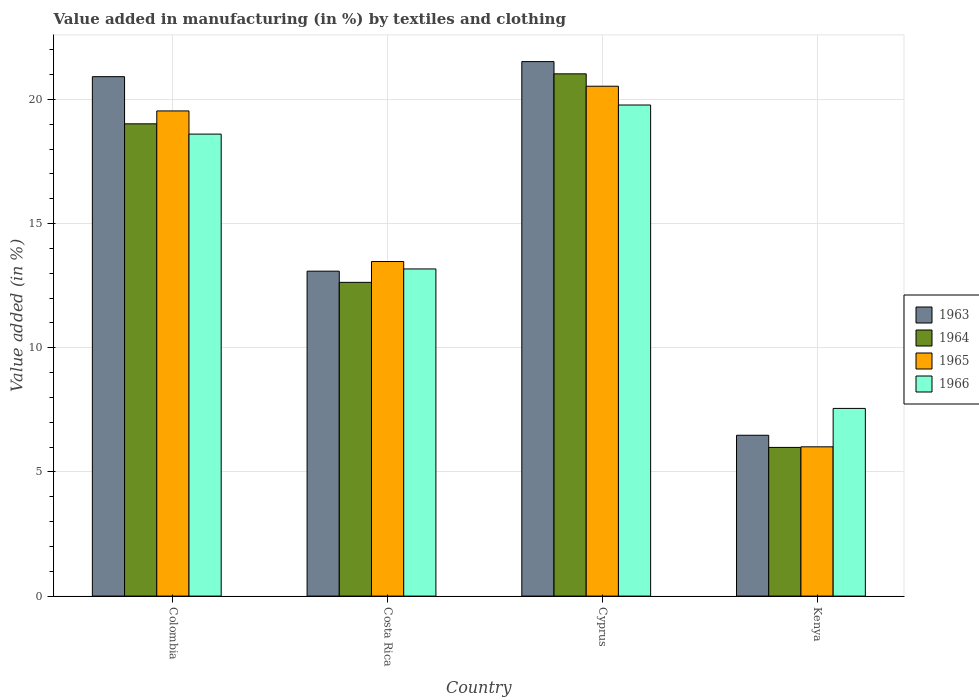How many groups of bars are there?
Keep it short and to the point. 4. Are the number of bars per tick equal to the number of legend labels?
Make the answer very short. Yes. How many bars are there on the 4th tick from the left?
Offer a terse response. 4. What is the label of the 3rd group of bars from the left?
Give a very brief answer. Cyprus. What is the percentage of value added in manufacturing by textiles and clothing in 1963 in Kenya?
Your answer should be compact. 6.48. Across all countries, what is the maximum percentage of value added in manufacturing by textiles and clothing in 1965?
Your response must be concise. 20.53. Across all countries, what is the minimum percentage of value added in manufacturing by textiles and clothing in 1963?
Your answer should be compact. 6.48. In which country was the percentage of value added in manufacturing by textiles and clothing in 1963 maximum?
Keep it short and to the point. Cyprus. In which country was the percentage of value added in manufacturing by textiles and clothing in 1965 minimum?
Keep it short and to the point. Kenya. What is the total percentage of value added in manufacturing by textiles and clothing in 1964 in the graph?
Your response must be concise. 58.67. What is the difference between the percentage of value added in manufacturing by textiles and clothing in 1964 in Cyprus and that in Kenya?
Your answer should be compact. 15.04. What is the difference between the percentage of value added in manufacturing by textiles and clothing in 1965 in Colombia and the percentage of value added in manufacturing by textiles and clothing in 1964 in Costa Rica?
Offer a very short reply. 6.9. What is the average percentage of value added in manufacturing by textiles and clothing in 1965 per country?
Your answer should be very brief. 14.89. What is the difference between the percentage of value added in manufacturing by textiles and clothing of/in 1965 and percentage of value added in manufacturing by textiles and clothing of/in 1966 in Colombia?
Ensure brevity in your answer.  0.93. What is the ratio of the percentage of value added in manufacturing by textiles and clothing in 1963 in Cyprus to that in Kenya?
Keep it short and to the point. 3.32. Is the percentage of value added in manufacturing by textiles and clothing in 1965 in Cyprus less than that in Kenya?
Provide a short and direct response. No. What is the difference between the highest and the second highest percentage of value added in manufacturing by textiles and clothing in 1965?
Offer a very short reply. -0.99. What is the difference between the highest and the lowest percentage of value added in manufacturing by textiles and clothing in 1963?
Make the answer very short. 15.05. What does the 4th bar from the left in Cyprus represents?
Your answer should be compact. 1966. What does the 1st bar from the right in Cyprus represents?
Offer a very short reply. 1966. Is it the case that in every country, the sum of the percentage of value added in manufacturing by textiles and clothing in 1963 and percentage of value added in manufacturing by textiles and clothing in 1964 is greater than the percentage of value added in manufacturing by textiles and clothing in 1966?
Offer a very short reply. Yes. How many bars are there?
Offer a very short reply. 16. Are all the bars in the graph horizontal?
Your answer should be compact. No. What is the difference between two consecutive major ticks on the Y-axis?
Provide a succinct answer. 5. Are the values on the major ticks of Y-axis written in scientific E-notation?
Give a very brief answer. No. Does the graph contain grids?
Offer a very short reply. Yes. Where does the legend appear in the graph?
Your answer should be compact. Center right. How are the legend labels stacked?
Your answer should be very brief. Vertical. What is the title of the graph?
Offer a terse response. Value added in manufacturing (in %) by textiles and clothing. Does "1970" appear as one of the legend labels in the graph?
Give a very brief answer. No. What is the label or title of the Y-axis?
Your answer should be compact. Value added (in %). What is the Value added (in %) in 1963 in Colombia?
Your response must be concise. 20.92. What is the Value added (in %) in 1964 in Colombia?
Offer a terse response. 19.02. What is the Value added (in %) of 1965 in Colombia?
Offer a very short reply. 19.54. What is the Value added (in %) of 1966 in Colombia?
Your answer should be very brief. 18.6. What is the Value added (in %) of 1963 in Costa Rica?
Offer a very short reply. 13.08. What is the Value added (in %) of 1964 in Costa Rica?
Offer a terse response. 12.63. What is the Value added (in %) of 1965 in Costa Rica?
Offer a very short reply. 13.47. What is the Value added (in %) in 1966 in Costa Rica?
Your answer should be very brief. 13.17. What is the Value added (in %) of 1963 in Cyprus?
Your response must be concise. 21.52. What is the Value added (in %) of 1964 in Cyprus?
Your answer should be very brief. 21.03. What is the Value added (in %) in 1965 in Cyprus?
Offer a terse response. 20.53. What is the Value added (in %) in 1966 in Cyprus?
Provide a succinct answer. 19.78. What is the Value added (in %) in 1963 in Kenya?
Your response must be concise. 6.48. What is the Value added (in %) in 1964 in Kenya?
Offer a very short reply. 5.99. What is the Value added (in %) in 1965 in Kenya?
Your answer should be very brief. 6.01. What is the Value added (in %) of 1966 in Kenya?
Your answer should be very brief. 7.56. Across all countries, what is the maximum Value added (in %) in 1963?
Make the answer very short. 21.52. Across all countries, what is the maximum Value added (in %) of 1964?
Keep it short and to the point. 21.03. Across all countries, what is the maximum Value added (in %) in 1965?
Give a very brief answer. 20.53. Across all countries, what is the maximum Value added (in %) in 1966?
Give a very brief answer. 19.78. Across all countries, what is the minimum Value added (in %) in 1963?
Offer a terse response. 6.48. Across all countries, what is the minimum Value added (in %) of 1964?
Make the answer very short. 5.99. Across all countries, what is the minimum Value added (in %) in 1965?
Provide a succinct answer. 6.01. Across all countries, what is the minimum Value added (in %) of 1966?
Give a very brief answer. 7.56. What is the total Value added (in %) of 1963 in the graph?
Provide a short and direct response. 62. What is the total Value added (in %) of 1964 in the graph?
Provide a short and direct response. 58.67. What is the total Value added (in %) of 1965 in the graph?
Give a very brief answer. 59.55. What is the total Value added (in %) of 1966 in the graph?
Provide a short and direct response. 59.11. What is the difference between the Value added (in %) of 1963 in Colombia and that in Costa Rica?
Your answer should be very brief. 7.83. What is the difference between the Value added (in %) in 1964 in Colombia and that in Costa Rica?
Your response must be concise. 6.38. What is the difference between the Value added (in %) of 1965 in Colombia and that in Costa Rica?
Provide a succinct answer. 6.06. What is the difference between the Value added (in %) in 1966 in Colombia and that in Costa Rica?
Offer a terse response. 5.43. What is the difference between the Value added (in %) of 1963 in Colombia and that in Cyprus?
Keep it short and to the point. -0.61. What is the difference between the Value added (in %) in 1964 in Colombia and that in Cyprus?
Your response must be concise. -2.01. What is the difference between the Value added (in %) of 1965 in Colombia and that in Cyprus?
Provide a short and direct response. -0.99. What is the difference between the Value added (in %) in 1966 in Colombia and that in Cyprus?
Your answer should be very brief. -1.17. What is the difference between the Value added (in %) in 1963 in Colombia and that in Kenya?
Your answer should be compact. 14.44. What is the difference between the Value added (in %) of 1964 in Colombia and that in Kenya?
Provide a succinct answer. 13.03. What is the difference between the Value added (in %) of 1965 in Colombia and that in Kenya?
Offer a very short reply. 13.53. What is the difference between the Value added (in %) in 1966 in Colombia and that in Kenya?
Your answer should be compact. 11.05. What is the difference between the Value added (in %) in 1963 in Costa Rica and that in Cyprus?
Give a very brief answer. -8.44. What is the difference between the Value added (in %) in 1964 in Costa Rica and that in Cyprus?
Make the answer very short. -8.4. What is the difference between the Value added (in %) of 1965 in Costa Rica and that in Cyprus?
Provide a short and direct response. -7.06. What is the difference between the Value added (in %) of 1966 in Costa Rica and that in Cyprus?
Offer a very short reply. -6.6. What is the difference between the Value added (in %) in 1963 in Costa Rica and that in Kenya?
Offer a very short reply. 6.61. What is the difference between the Value added (in %) of 1964 in Costa Rica and that in Kenya?
Make the answer very short. 6.65. What is the difference between the Value added (in %) in 1965 in Costa Rica and that in Kenya?
Ensure brevity in your answer.  7.46. What is the difference between the Value added (in %) in 1966 in Costa Rica and that in Kenya?
Make the answer very short. 5.62. What is the difference between the Value added (in %) of 1963 in Cyprus and that in Kenya?
Ensure brevity in your answer.  15.05. What is the difference between the Value added (in %) of 1964 in Cyprus and that in Kenya?
Your answer should be compact. 15.04. What is the difference between the Value added (in %) in 1965 in Cyprus and that in Kenya?
Keep it short and to the point. 14.52. What is the difference between the Value added (in %) in 1966 in Cyprus and that in Kenya?
Ensure brevity in your answer.  12.22. What is the difference between the Value added (in %) of 1963 in Colombia and the Value added (in %) of 1964 in Costa Rica?
Keep it short and to the point. 8.28. What is the difference between the Value added (in %) in 1963 in Colombia and the Value added (in %) in 1965 in Costa Rica?
Your answer should be very brief. 7.44. What is the difference between the Value added (in %) in 1963 in Colombia and the Value added (in %) in 1966 in Costa Rica?
Provide a succinct answer. 7.74. What is the difference between the Value added (in %) in 1964 in Colombia and the Value added (in %) in 1965 in Costa Rica?
Give a very brief answer. 5.55. What is the difference between the Value added (in %) of 1964 in Colombia and the Value added (in %) of 1966 in Costa Rica?
Provide a short and direct response. 5.84. What is the difference between the Value added (in %) in 1965 in Colombia and the Value added (in %) in 1966 in Costa Rica?
Give a very brief answer. 6.36. What is the difference between the Value added (in %) in 1963 in Colombia and the Value added (in %) in 1964 in Cyprus?
Make the answer very short. -0.11. What is the difference between the Value added (in %) in 1963 in Colombia and the Value added (in %) in 1965 in Cyprus?
Provide a short and direct response. 0.39. What is the difference between the Value added (in %) of 1963 in Colombia and the Value added (in %) of 1966 in Cyprus?
Your response must be concise. 1.14. What is the difference between the Value added (in %) in 1964 in Colombia and the Value added (in %) in 1965 in Cyprus?
Ensure brevity in your answer.  -1.51. What is the difference between the Value added (in %) in 1964 in Colombia and the Value added (in %) in 1966 in Cyprus?
Offer a terse response. -0.76. What is the difference between the Value added (in %) in 1965 in Colombia and the Value added (in %) in 1966 in Cyprus?
Offer a very short reply. -0.24. What is the difference between the Value added (in %) in 1963 in Colombia and the Value added (in %) in 1964 in Kenya?
Your answer should be compact. 14.93. What is the difference between the Value added (in %) of 1963 in Colombia and the Value added (in %) of 1965 in Kenya?
Offer a terse response. 14.91. What is the difference between the Value added (in %) in 1963 in Colombia and the Value added (in %) in 1966 in Kenya?
Provide a short and direct response. 13.36. What is the difference between the Value added (in %) in 1964 in Colombia and the Value added (in %) in 1965 in Kenya?
Offer a very short reply. 13.01. What is the difference between the Value added (in %) in 1964 in Colombia and the Value added (in %) in 1966 in Kenya?
Provide a succinct answer. 11.46. What is the difference between the Value added (in %) of 1965 in Colombia and the Value added (in %) of 1966 in Kenya?
Offer a terse response. 11.98. What is the difference between the Value added (in %) of 1963 in Costa Rica and the Value added (in %) of 1964 in Cyprus?
Provide a short and direct response. -7.95. What is the difference between the Value added (in %) of 1963 in Costa Rica and the Value added (in %) of 1965 in Cyprus?
Your answer should be very brief. -7.45. What is the difference between the Value added (in %) of 1963 in Costa Rica and the Value added (in %) of 1966 in Cyprus?
Provide a short and direct response. -6.69. What is the difference between the Value added (in %) of 1964 in Costa Rica and the Value added (in %) of 1965 in Cyprus?
Keep it short and to the point. -7.9. What is the difference between the Value added (in %) in 1964 in Costa Rica and the Value added (in %) in 1966 in Cyprus?
Ensure brevity in your answer.  -7.14. What is the difference between the Value added (in %) of 1965 in Costa Rica and the Value added (in %) of 1966 in Cyprus?
Your answer should be compact. -6.3. What is the difference between the Value added (in %) of 1963 in Costa Rica and the Value added (in %) of 1964 in Kenya?
Offer a very short reply. 7.1. What is the difference between the Value added (in %) in 1963 in Costa Rica and the Value added (in %) in 1965 in Kenya?
Offer a very short reply. 7.07. What is the difference between the Value added (in %) in 1963 in Costa Rica and the Value added (in %) in 1966 in Kenya?
Make the answer very short. 5.53. What is the difference between the Value added (in %) in 1964 in Costa Rica and the Value added (in %) in 1965 in Kenya?
Your answer should be compact. 6.62. What is the difference between the Value added (in %) in 1964 in Costa Rica and the Value added (in %) in 1966 in Kenya?
Give a very brief answer. 5.08. What is the difference between the Value added (in %) in 1965 in Costa Rica and the Value added (in %) in 1966 in Kenya?
Your response must be concise. 5.91. What is the difference between the Value added (in %) of 1963 in Cyprus and the Value added (in %) of 1964 in Kenya?
Provide a succinct answer. 15.54. What is the difference between the Value added (in %) of 1963 in Cyprus and the Value added (in %) of 1965 in Kenya?
Your answer should be compact. 15.51. What is the difference between the Value added (in %) in 1963 in Cyprus and the Value added (in %) in 1966 in Kenya?
Provide a succinct answer. 13.97. What is the difference between the Value added (in %) in 1964 in Cyprus and the Value added (in %) in 1965 in Kenya?
Offer a terse response. 15.02. What is the difference between the Value added (in %) of 1964 in Cyprus and the Value added (in %) of 1966 in Kenya?
Keep it short and to the point. 13.47. What is the difference between the Value added (in %) of 1965 in Cyprus and the Value added (in %) of 1966 in Kenya?
Your answer should be very brief. 12.97. What is the average Value added (in %) of 1963 per country?
Provide a succinct answer. 15.5. What is the average Value added (in %) in 1964 per country?
Give a very brief answer. 14.67. What is the average Value added (in %) of 1965 per country?
Your response must be concise. 14.89. What is the average Value added (in %) in 1966 per country?
Give a very brief answer. 14.78. What is the difference between the Value added (in %) in 1963 and Value added (in %) in 1964 in Colombia?
Keep it short and to the point. 1.9. What is the difference between the Value added (in %) in 1963 and Value added (in %) in 1965 in Colombia?
Your answer should be compact. 1.38. What is the difference between the Value added (in %) of 1963 and Value added (in %) of 1966 in Colombia?
Your answer should be very brief. 2.31. What is the difference between the Value added (in %) in 1964 and Value added (in %) in 1965 in Colombia?
Offer a very short reply. -0.52. What is the difference between the Value added (in %) in 1964 and Value added (in %) in 1966 in Colombia?
Make the answer very short. 0.41. What is the difference between the Value added (in %) in 1965 and Value added (in %) in 1966 in Colombia?
Give a very brief answer. 0.93. What is the difference between the Value added (in %) in 1963 and Value added (in %) in 1964 in Costa Rica?
Ensure brevity in your answer.  0.45. What is the difference between the Value added (in %) of 1963 and Value added (in %) of 1965 in Costa Rica?
Your answer should be very brief. -0.39. What is the difference between the Value added (in %) of 1963 and Value added (in %) of 1966 in Costa Rica?
Keep it short and to the point. -0.09. What is the difference between the Value added (in %) in 1964 and Value added (in %) in 1965 in Costa Rica?
Keep it short and to the point. -0.84. What is the difference between the Value added (in %) in 1964 and Value added (in %) in 1966 in Costa Rica?
Keep it short and to the point. -0.54. What is the difference between the Value added (in %) of 1965 and Value added (in %) of 1966 in Costa Rica?
Your answer should be compact. 0.3. What is the difference between the Value added (in %) of 1963 and Value added (in %) of 1964 in Cyprus?
Make the answer very short. 0.49. What is the difference between the Value added (in %) of 1963 and Value added (in %) of 1965 in Cyprus?
Your answer should be compact. 0.99. What is the difference between the Value added (in %) of 1963 and Value added (in %) of 1966 in Cyprus?
Ensure brevity in your answer.  1.75. What is the difference between the Value added (in %) of 1964 and Value added (in %) of 1965 in Cyprus?
Ensure brevity in your answer.  0.5. What is the difference between the Value added (in %) in 1964 and Value added (in %) in 1966 in Cyprus?
Give a very brief answer. 1.25. What is the difference between the Value added (in %) in 1965 and Value added (in %) in 1966 in Cyprus?
Make the answer very short. 0.76. What is the difference between the Value added (in %) of 1963 and Value added (in %) of 1964 in Kenya?
Your answer should be very brief. 0.49. What is the difference between the Value added (in %) of 1963 and Value added (in %) of 1965 in Kenya?
Your answer should be very brief. 0.47. What is the difference between the Value added (in %) of 1963 and Value added (in %) of 1966 in Kenya?
Your answer should be compact. -1.08. What is the difference between the Value added (in %) in 1964 and Value added (in %) in 1965 in Kenya?
Your answer should be very brief. -0.02. What is the difference between the Value added (in %) in 1964 and Value added (in %) in 1966 in Kenya?
Provide a short and direct response. -1.57. What is the difference between the Value added (in %) in 1965 and Value added (in %) in 1966 in Kenya?
Give a very brief answer. -1.55. What is the ratio of the Value added (in %) of 1963 in Colombia to that in Costa Rica?
Give a very brief answer. 1.6. What is the ratio of the Value added (in %) in 1964 in Colombia to that in Costa Rica?
Provide a short and direct response. 1.51. What is the ratio of the Value added (in %) of 1965 in Colombia to that in Costa Rica?
Your answer should be compact. 1.45. What is the ratio of the Value added (in %) in 1966 in Colombia to that in Costa Rica?
Offer a very short reply. 1.41. What is the ratio of the Value added (in %) in 1963 in Colombia to that in Cyprus?
Make the answer very short. 0.97. What is the ratio of the Value added (in %) of 1964 in Colombia to that in Cyprus?
Make the answer very short. 0.9. What is the ratio of the Value added (in %) of 1965 in Colombia to that in Cyprus?
Offer a terse response. 0.95. What is the ratio of the Value added (in %) of 1966 in Colombia to that in Cyprus?
Keep it short and to the point. 0.94. What is the ratio of the Value added (in %) of 1963 in Colombia to that in Kenya?
Offer a terse response. 3.23. What is the ratio of the Value added (in %) in 1964 in Colombia to that in Kenya?
Ensure brevity in your answer.  3.18. What is the ratio of the Value added (in %) in 1965 in Colombia to that in Kenya?
Offer a terse response. 3.25. What is the ratio of the Value added (in %) of 1966 in Colombia to that in Kenya?
Your answer should be compact. 2.46. What is the ratio of the Value added (in %) in 1963 in Costa Rica to that in Cyprus?
Keep it short and to the point. 0.61. What is the ratio of the Value added (in %) of 1964 in Costa Rica to that in Cyprus?
Provide a succinct answer. 0.6. What is the ratio of the Value added (in %) in 1965 in Costa Rica to that in Cyprus?
Provide a short and direct response. 0.66. What is the ratio of the Value added (in %) in 1966 in Costa Rica to that in Cyprus?
Provide a succinct answer. 0.67. What is the ratio of the Value added (in %) of 1963 in Costa Rica to that in Kenya?
Provide a succinct answer. 2.02. What is the ratio of the Value added (in %) in 1964 in Costa Rica to that in Kenya?
Keep it short and to the point. 2.11. What is the ratio of the Value added (in %) in 1965 in Costa Rica to that in Kenya?
Ensure brevity in your answer.  2.24. What is the ratio of the Value added (in %) in 1966 in Costa Rica to that in Kenya?
Give a very brief answer. 1.74. What is the ratio of the Value added (in %) in 1963 in Cyprus to that in Kenya?
Give a very brief answer. 3.32. What is the ratio of the Value added (in %) of 1964 in Cyprus to that in Kenya?
Offer a terse response. 3.51. What is the ratio of the Value added (in %) of 1965 in Cyprus to that in Kenya?
Make the answer very short. 3.42. What is the ratio of the Value added (in %) in 1966 in Cyprus to that in Kenya?
Your response must be concise. 2.62. What is the difference between the highest and the second highest Value added (in %) of 1963?
Make the answer very short. 0.61. What is the difference between the highest and the second highest Value added (in %) of 1964?
Keep it short and to the point. 2.01. What is the difference between the highest and the second highest Value added (in %) of 1965?
Offer a very short reply. 0.99. What is the difference between the highest and the second highest Value added (in %) of 1966?
Ensure brevity in your answer.  1.17. What is the difference between the highest and the lowest Value added (in %) in 1963?
Make the answer very short. 15.05. What is the difference between the highest and the lowest Value added (in %) in 1964?
Provide a short and direct response. 15.04. What is the difference between the highest and the lowest Value added (in %) in 1965?
Offer a very short reply. 14.52. What is the difference between the highest and the lowest Value added (in %) of 1966?
Your answer should be very brief. 12.22. 